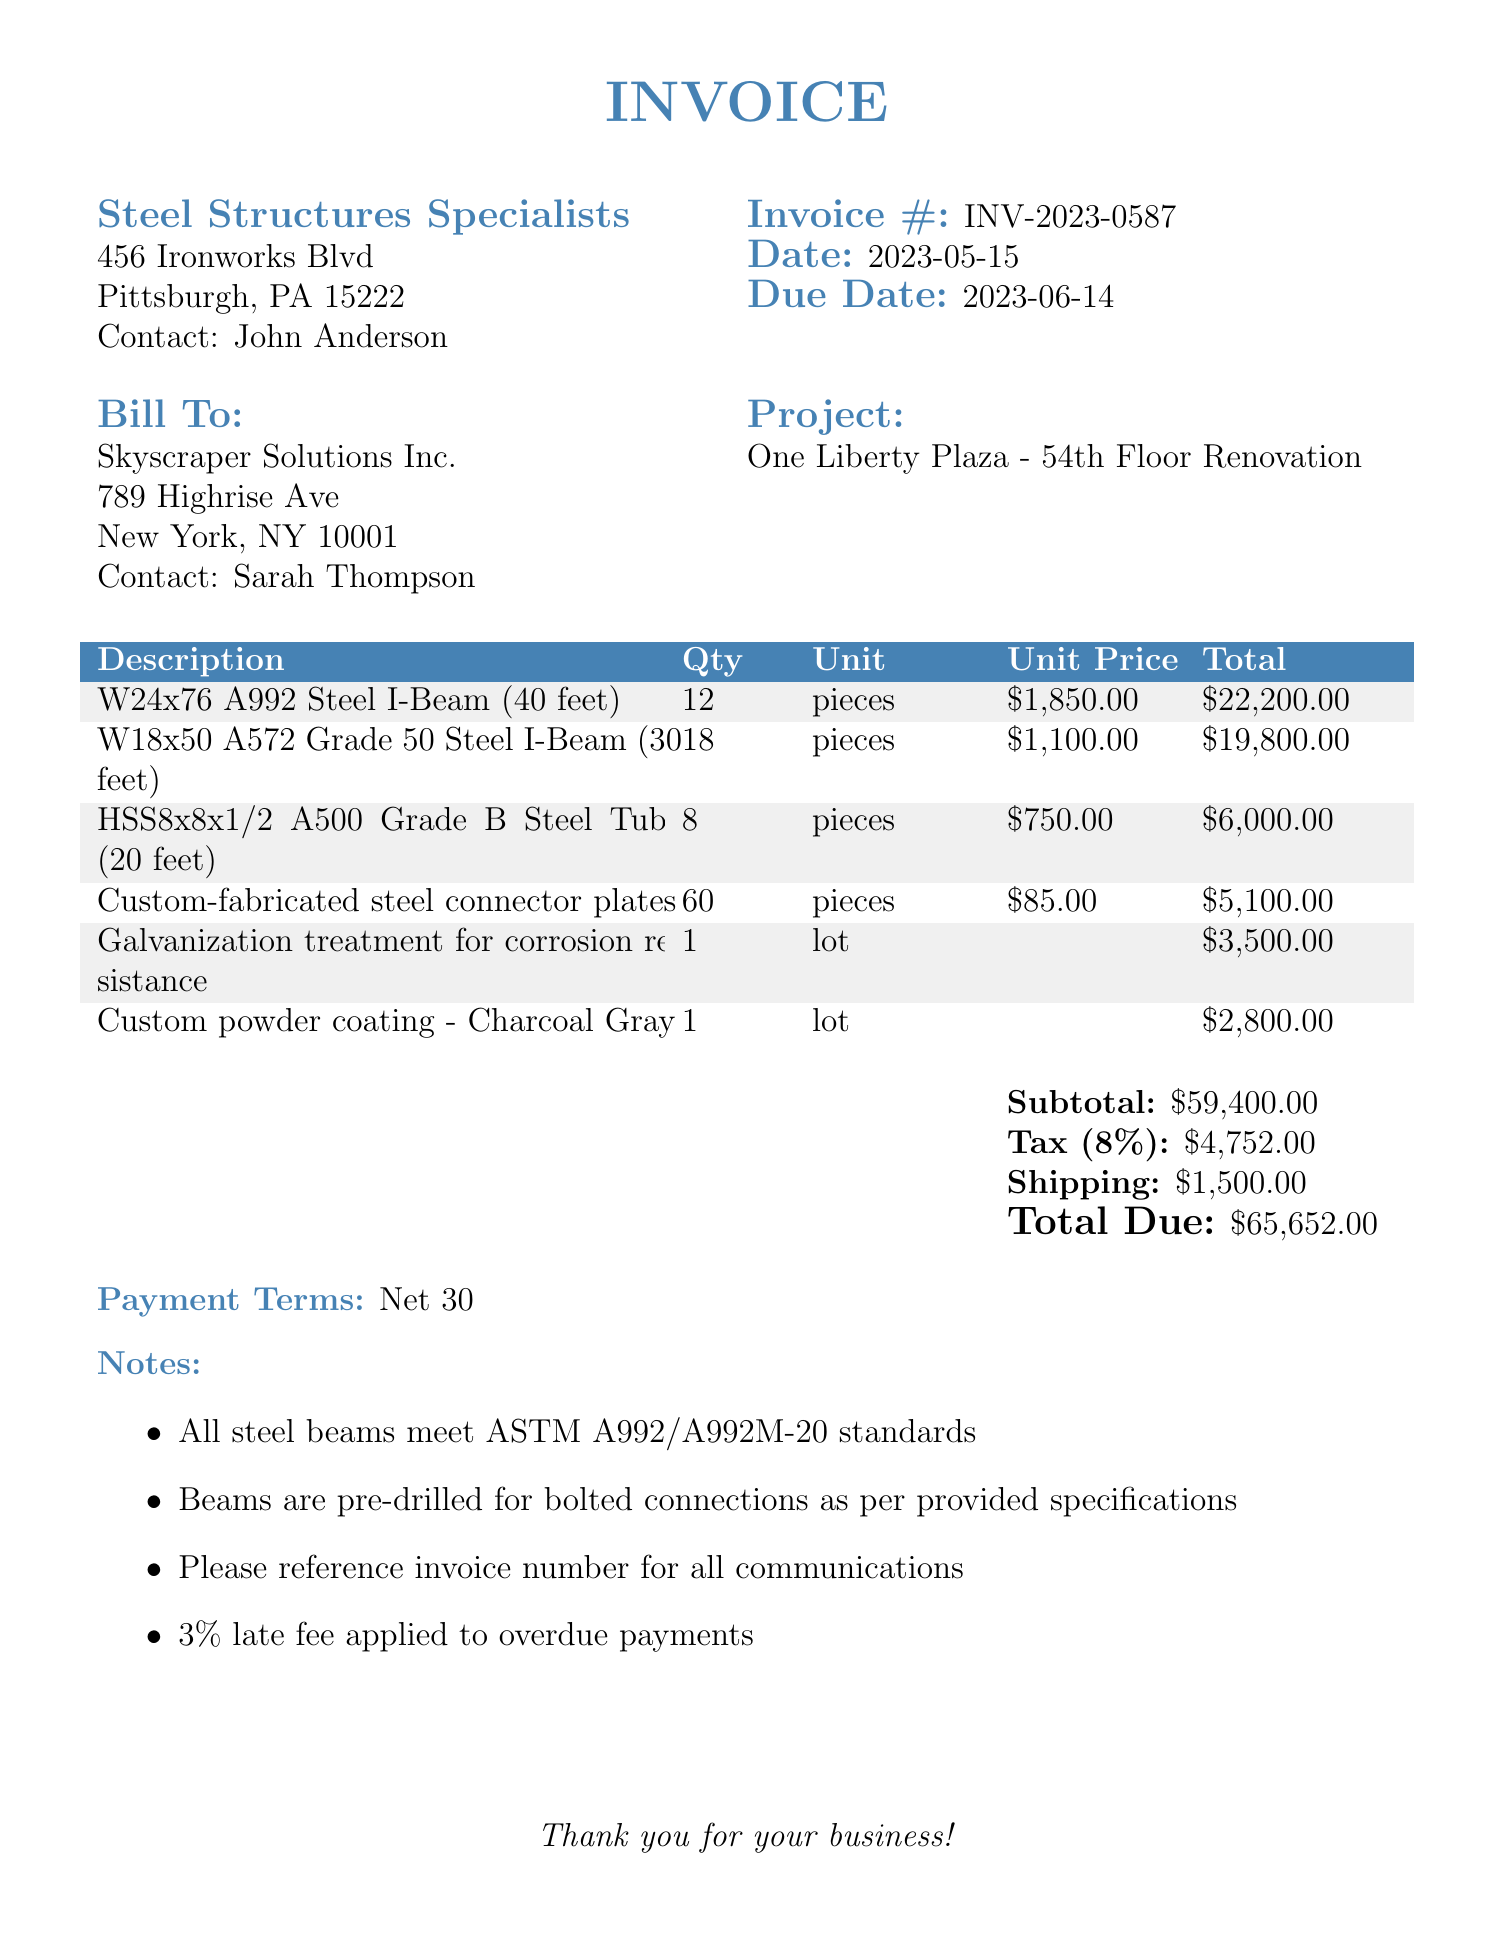What is the invoice number? The invoice number is a unique identifier for the document, listed prominently.
Answer: INV-2023-0587 Who is the supplier? The supplier is the company providing the steel beams and services, mentioned at the top of the invoice.
Answer: Steel Structures Specialists What is the total due amount? The total due is calculated at the bottom of the invoice, including subtotal, tax, and shipping.
Answer: $65,652.00 How many W24x76 A992 Steel I-Beams were ordered? The quantity for the specific item is listed in the itemized section.
Answer: 12 What is the due date for the invoice? The due date indicates when payment should be made and is mentioned next to the invoice number.
Answer: 2023-06-14 What services were added to the invoice? This asks for the specific additional services listed on the invoice.
Answer: Galvanization treatment for corrosion resistance, Custom powder coating - Charcoal Gray How many custom-fabricated steel connector plates were supplied? The quantity for custom-fabricated items is specified in the itemized section.
Answer: 60 What is the tax rate applied to the invoice? The tax rate is listed in the subtotal section and is applied to calculate the total tax amount.
Answer: 8% What is the project name associated with this invoice? The project name is identified in the billing section of the invoice.
Answer: One Liberty Plaza - 54th Floor Renovation 